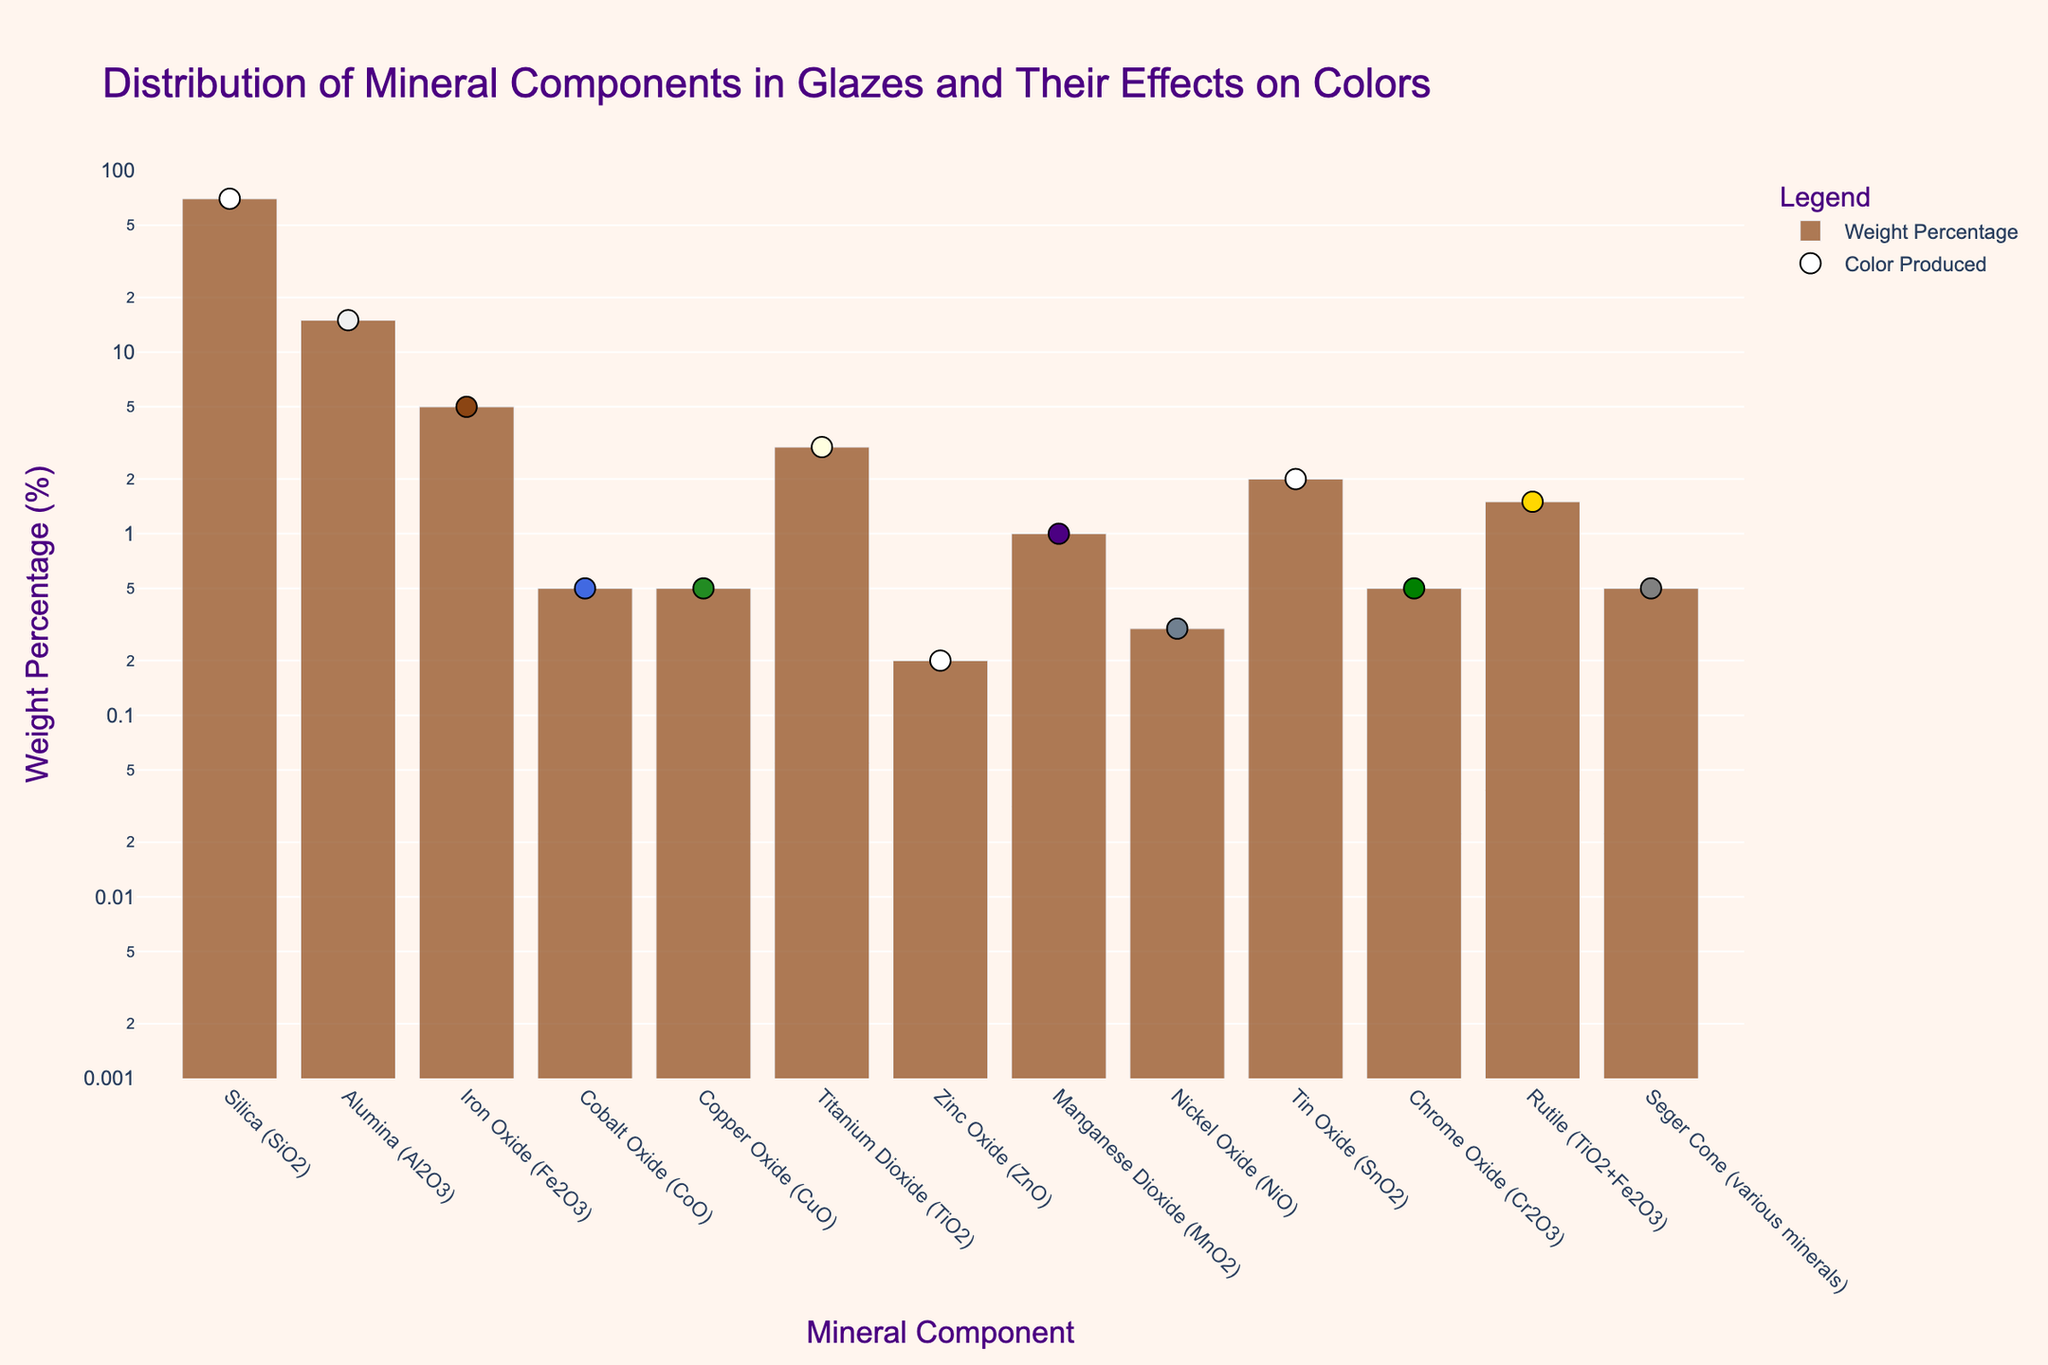Which mineral component has the highest weight percentage? The bar chart shows that Silica (SiO2) has the tallest bar on the y-axis. From this, we can infer it has the highest weight percentage.
Answer: Silica (SiO2) How many mineral components have their weight percentages below 1%? By observing the bar chart and noting the heights, the components with bars below 1% are Cobalt Oxide (CoO), Copper Oxide (CuO), Zinc Oxide (ZnO), Nickel Oxide (NiO), Chrome Oxide (Cr2O3), and Seger Cone.
Answer: 6 Which mineral components produce a transparent color in the glaze? From the scatter plot and corresponding colors indicated by the points, the mineral components listed as producing a transparent color are Silica (SiO2) and Zinc Oxide (ZnO).
Answer: Silica (SiO2), Zinc Oxide (ZnO) What is the combined weight percentage of Titanium Dioxide (TiO2) and Rutile? Titanium Dioxide (TiO2) has a weight percentage of 3% and Rutile has a weight percentage of 1.5%. Summing these up, (3 + 1.5) = 4.5%.
Answer: 4.5% Which mineral component has the smallest weight percentage, and what color does it produce? By looking at the shortest bar on the y-axis, we find that Zinc Oxide (ZnO) has the smallest weight percentage, which produces a transparent color.
Answer: Zinc Oxide (ZnO), Transparent How does the weight percentage of Iron Oxide (Fe2O3) compare to that of Alumina (Al2O3)? Observing the bars, Iron Oxide (Fe2O3) shows a weight percentage of 5%, while Alumina (Al2O3) shows 15%. Iron Oxide (Fe2O3) is smaller than Alumina (Al2O3).
Answer: Smaller What is the range of weight percentages shown in the plot? The y-axis is set on a log scale and ranges from 0.1% to 100%. This can be inferred from the smallest and largest values present in the plot.
Answer: 0.1% to 100% What color is produced by the mineral component with a 1% weight percentage? By identifying the data point with a 1% weight percentage on the scatter plot, we determine the color produced by Manganese Dioxide (MnO2) is Purple/Black.
Answer: Purple/Black 